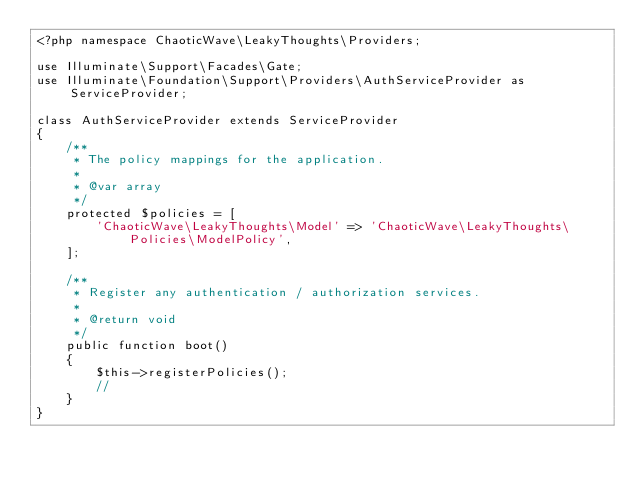<code> <loc_0><loc_0><loc_500><loc_500><_PHP_><?php namespace ChaoticWave\LeakyThoughts\Providers;

use Illuminate\Support\Facades\Gate;
use Illuminate\Foundation\Support\Providers\AuthServiceProvider as ServiceProvider;

class AuthServiceProvider extends ServiceProvider
{
    /**
     * The policy mappings for the application.
     *
     * @var array
     */
    protected $policies = [
        'ChaoticWave\LeakyThoughts\Model' => 'ChaoticWave\LeakyThoughts\Policies\ModelPolicy',
    ];

    /**
     * Register any authentication / authorization services.
     *
     * @return void
     */
    public function boot()
    {
        $this->registerPolicies();
        //
    }
}
</code> 